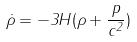Convert formula to latex. <formula><loc_0><loc_0><loc_500><loc_500>\dot { \rho } = - 3 H ( \rho + \frac { p } { c ^ { 2 } } )</formula> 